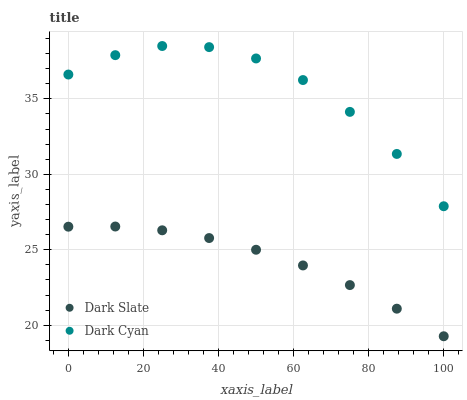Does Dark Slate have the minimum area under the curve?
Answer yes or no. Yes. Does Dark Cyan have the maximum area under the curve?
Answer yes or no. Yes. Does Dark Slate have the maximum area under the curve?
Answer yes or no. No. Is Dark Slate the smoothest?
Answer yes or no. Yes. Is Dark Cyan the roughest?
Answer yes or no. Yes. Is Dark Slate the roughest?
Answer yes or no. No. Does Dark Slate have the lowest value?
Answer yes or no. Yes. Does Dark Cyan have the highest value?
Answer yes or no. Yes. Does Dark Slate have the highest value?
Answer yes or no. No. Is Dark Slate less than Dark Cyan?
Answer yes or no. Yes. Is Dark Cyan greater than Dark Slate?
Answer yes or no. Yes. Does Dark Slate intersect Dark Cyan?
Answer yes or no. No. 